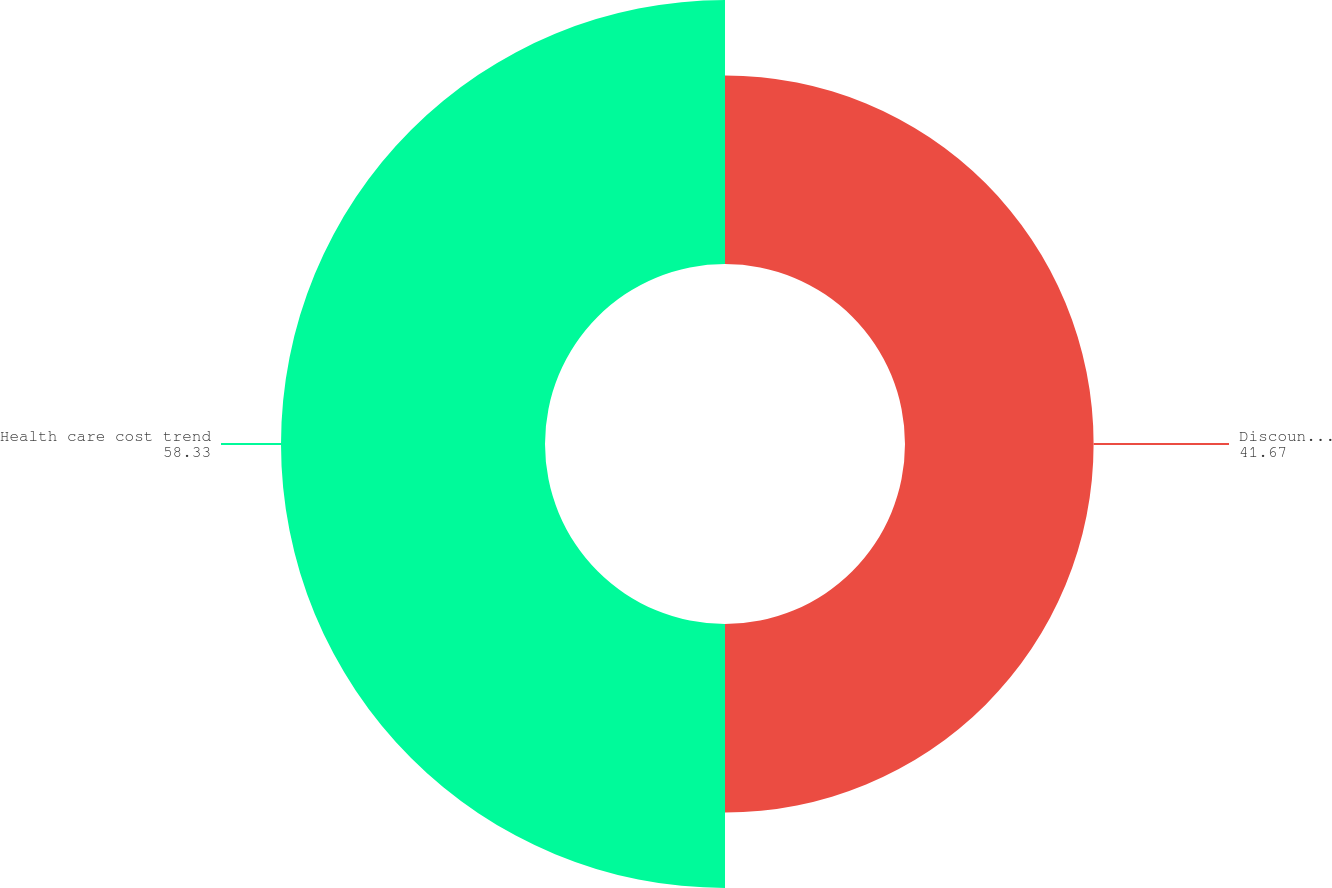<chart> <loc_0><loc_0><loc_500><loc_500><pie_chart><fcel>Discount rate<fcel>Health care cost trend<nl><fcel>41.67%<fcel>58.33%<nl></chart> 